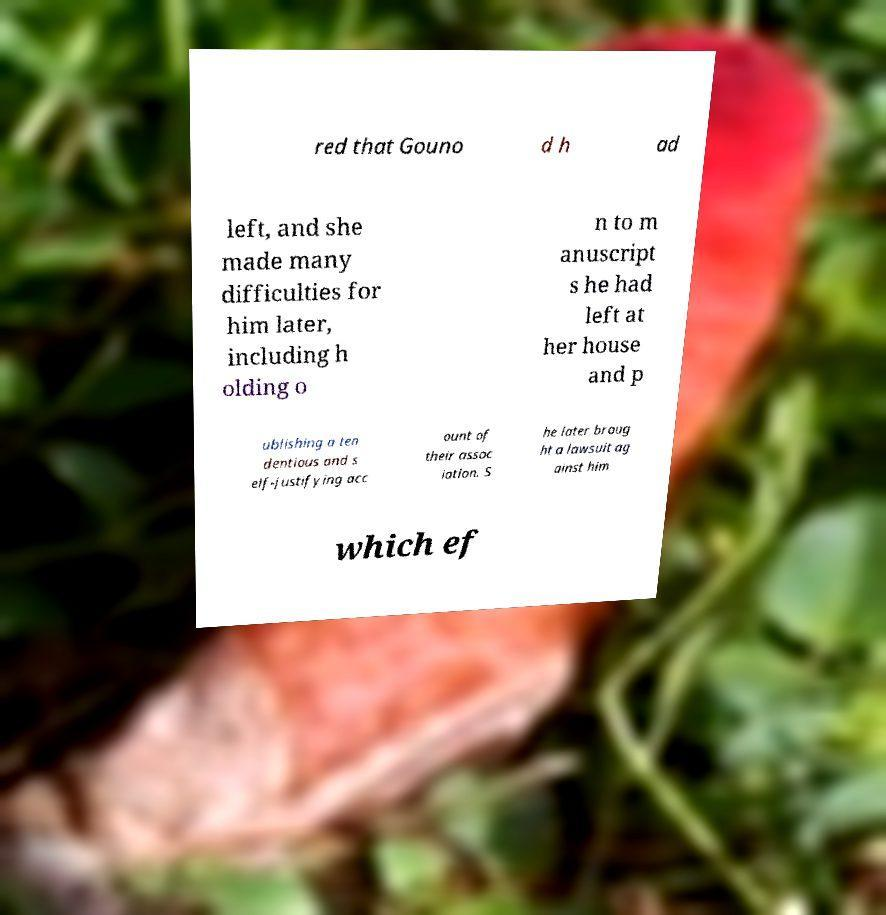Could you extract and type out the text from this image? red that Gouno d h ad left, and she made many difficulties for him later, including h olding o n to m anuscript s he had left at her house and p ublishing a ten dentious and s elf-justifying acc ount of their assoc iation. S he later broug ht a lawsuit ag ainst him which ef 